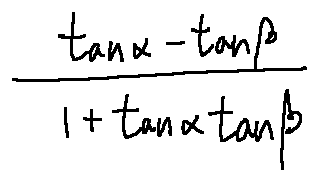Convert formula to latex. <formula><loc_0><loc_0><loc_500><loc_500>\frac { \tan \alpha - \tan \beta } { 1 + \tan \alpha \tan \beta }</formula> 